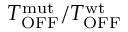Convert formula to latex. <formula><loc_0><loc_0><loc_500><loc_500>T _ { O F F } ^ { m u t } / T _ { O F F } ^ { w t }</formula> 